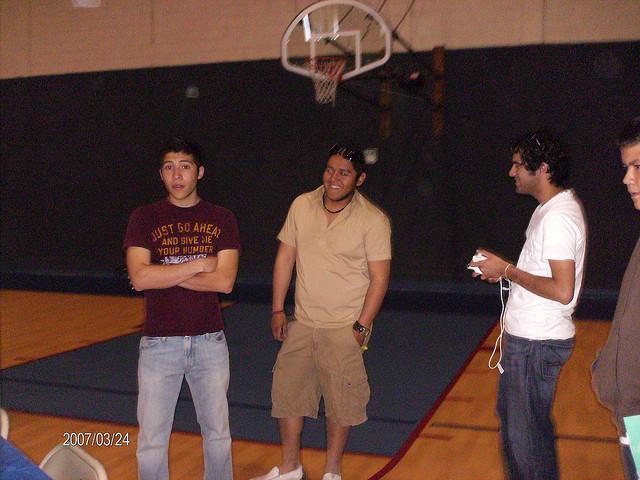What event is the man participating in?
Answer briefly. Basketball. Where are they?
Be succinct. Gym. How many kids are there?
Write a very short answer. 4. Is this occurring at an event?
Keep it brief. Yes. Is the man holding a microphone in one of his hands?
Answer briefly. No. Is the man in motion?
Short answer required. No. What court are they standing on?
Keep it brief. Basketball. What is the man doing?
Concise answer only. Smiling. Where is this taken?
Write a very short answer. Gym. Is there somebody with crossed legs in this picture?
Give a very brief answer. No. What kind of console do these people have?
Short answer required. Wii. How many people are wearing shorts?
Keep it brief. 1. 